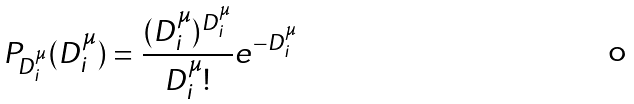Convert formula to latex. <formula><loc_0><loc_0><loc_500><loc_500>P _ { D ^ { \mu } _ { i } } ( D ^ { \mu } _ { i } ) = \frac { ( D ^ { \mu } _ { i } ) ^ { D ^ { \mu } _ { i } } } { D ^ { \mu } _ { i } ! } e ^ { - D ^ { \mu } _ { i } }</formula> 